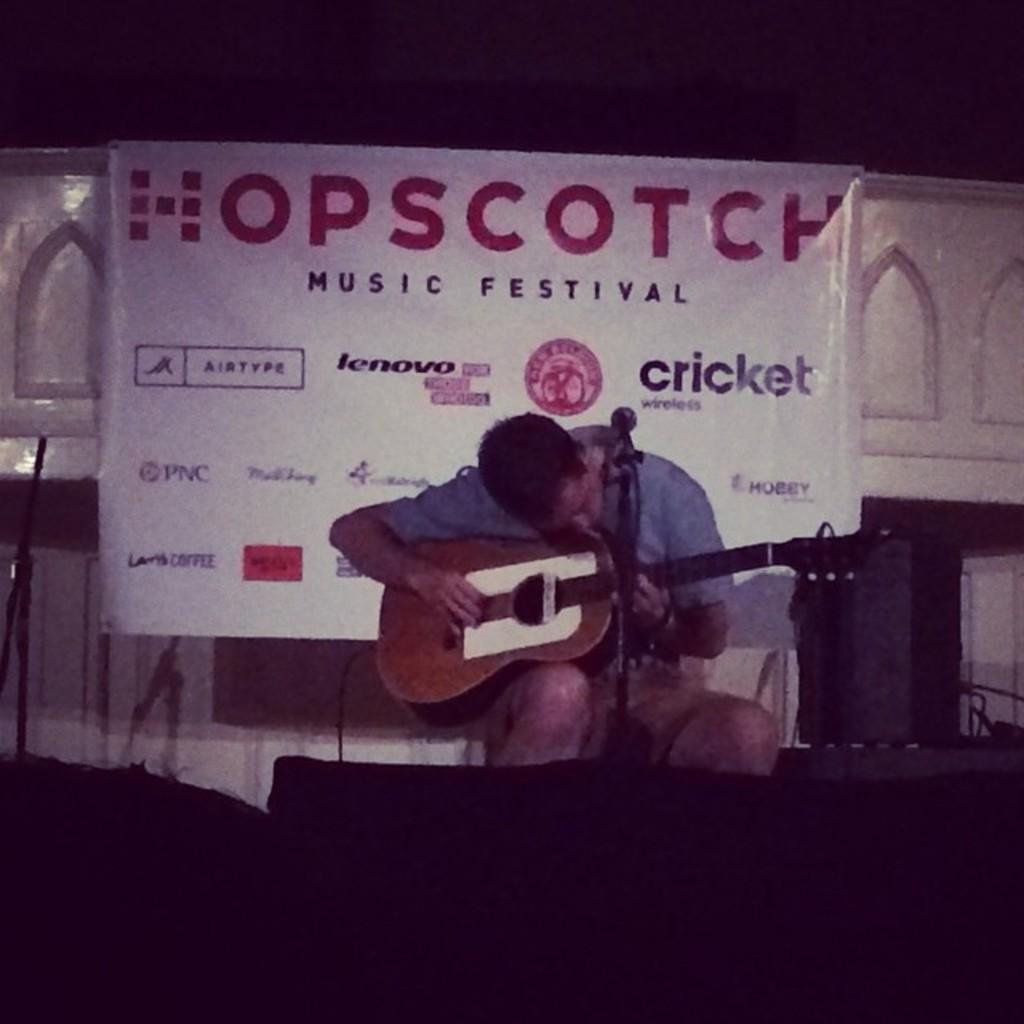Could you give a brief overview of what you see in this image? In this image I see a person who is sitting and holding a guitar and the person is in front of a mic. In the background I see the banner. 